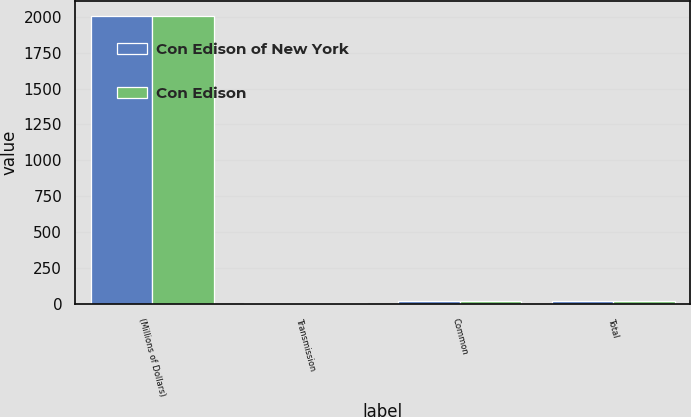Convert chart. <chart><loc_0><loc_0><loc_500><loc_500><stacked_bar_chart><ecel><fcel>(Millions of Dollars)<fcel>Transmission<fcel>Common<fcel>Total<nl><fcel>Con Edison of New York<fcel>2008<fcel>5<fcel>17<fcel>22<nl><fcel>Con Edison<fcel>2008<fcel>5<fcel>17<fcel>22<nl></chart> 